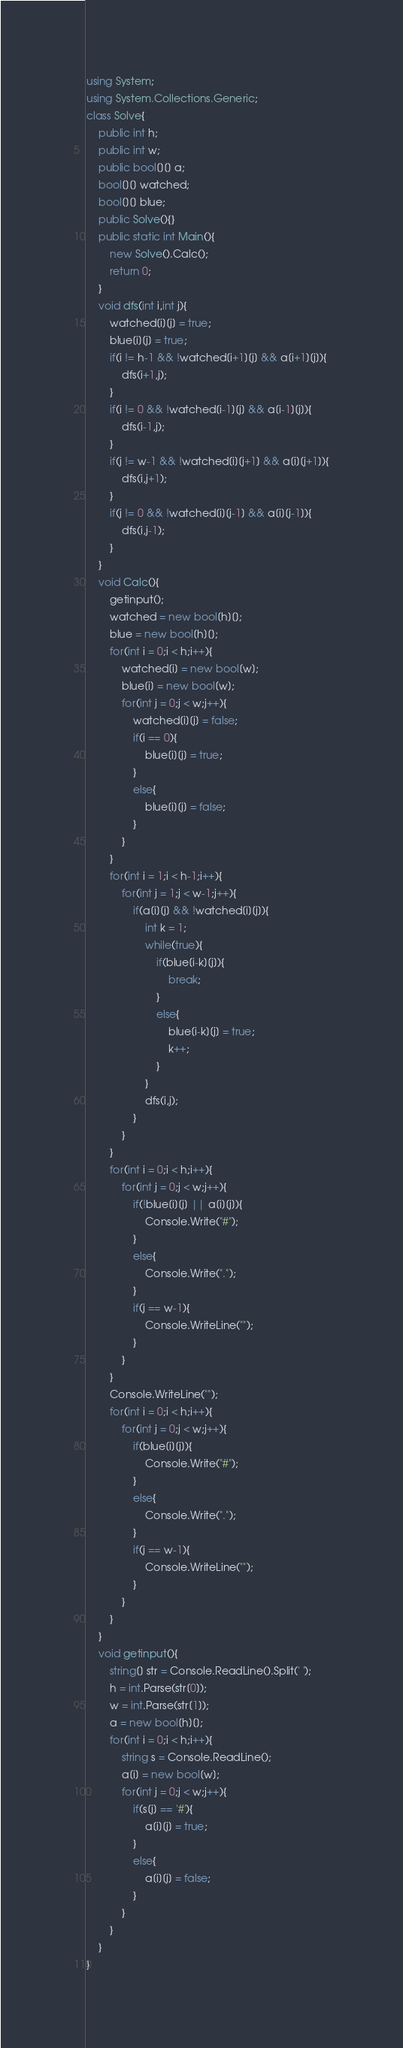<code> <loc_0><loc_0><loc_500><loc_500><_C#_>using System;
using System.Collections.Generic;
class Solve{
    public int h;
    public int w;
    public bool[][] a;
    bool[][] watched;
    bool[][] blue;
    public Solve(){}
    public static int Main(){
        new Solve().Calc();
        return 0;
    }
    void dfs(int i,int j){
        watched[i][j] = true;
        blue[i][j] = true;
        if(i != h-1 && !watched[i+1][j] && a[i+1][j]){
            dfs(i+1,j);
        }
        if(i != 0 && !watched[i-1][j] && a[i-1][j]){
            dfs(i-1,j);
        }
        if(j != w-1 && !watched[i][j+1] && a[i][j+1]){
            dfs(i,j+1);
        }
        if(j != 0 && !watched[i][j-1] && a[i][j-1]){
            dfs(i,j-1);
        }
    }
    void Calc(){
        getinput();
        watched = new bool[h][];
        blue = new bool[h][];
        for(int i = 0;i < h;i++){
            watched[i] = new bool[w];
            blue[i] = new bool[w];
            for(int j = 0;j < w;j++){
                watched[i][j] = false;
                if(i == 0){
                    blue[i][j] = true;
                }
                else{
                    blue[i][j] = false;
                }
            }
        }
        for(int i = 1;i < h-1;i++){
            for(int j = 1;j < w-1;j++){
                if(a[i][j] && !watched[i][j]){
                    int k = 1;
                    while(true){
                        if(blue[i-k][j]){
                            break;
                        }
                        else{
                            blue[i-k][j] = true;
                            k++;
                        }
                    }
                    dfs(i,j);
                }
            }
        }
        for(int i = 0;i < h;i++){
            for(int j = 0;j < w;j++){
                if(!blue[i][j] || a[i][j]){
                    Console.Write("#");
                }
                else{
                    Console.Write(".");
                }
                if(j == w-1){
                    Console.WriteLine("");
                }
            }
        }
        Console.WriteLine("");
        for(int i = 0;i < h;i++){
            for(int j = 0;j < w;j++){
                if(blue[i][j]){
                    Console.Write("#");
                }
                else{
                    Console.Write(".");
                }
                if(j == w-1){
                    Console.WriteLine("");
                }
            }
        }
    }
    void getinput(){
        string[] str = Console.ReadLine().Split(' ');
        h = int.Parse(str[0]);
        w = int.Parse(str[1]);
        a = new bool[h][];
        for(int i = 0;i < h;i++){
            string s = Console.ReadLine();
            a[i] = new bool[w];
            for(int j = 0;j < w;j++){
                if(s[j] == '#'){
                    a[i][j] = true;
                }
                else{
                    a[i][j] = false;
                }
            }
        }
    }    
}</code> 